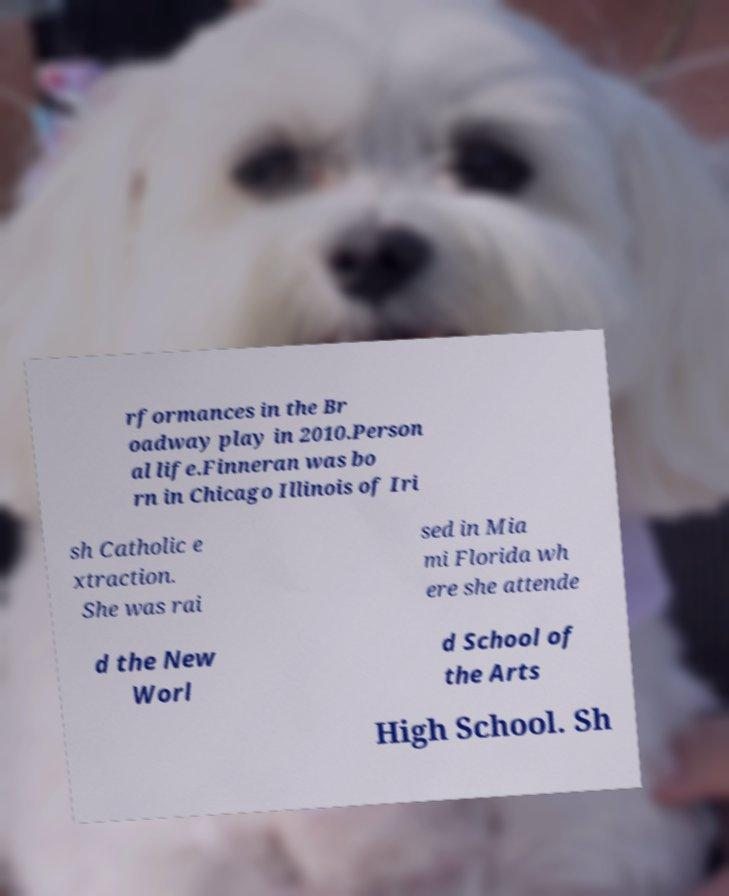Could you extract and type out the text from this image? rformances in the Br oadway play in 2010.Person al life.Finneran was bo rn in Chicago Illinois of Iri sh Catholic e xtraction. She was rai sed in Mia mi Florida wh ere she attende d the New Worl d School of the Arts High School. Sh 